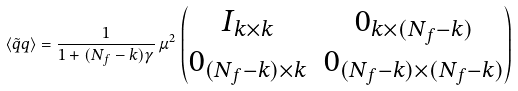Convert formula to latex. <formula><loc_0><loc_0><loc_500><loc_500>\langle \tilde { q } q \rangle = \frac { 1 } { 1 + ( N _ { f } - k ) \gamma } \, \mu ^ { 2 } \, \left ( \begin{matrix} I _ { k \times k } & 0 _ { k \times ( N _ { f } - k ) } \\ 0 _ { ( N _ { f } - k ) \times k } & 0 _ { ( N _ { f } - k ) \times ( N _ { f } - k ) } \end{matrix} \right )</formula> 